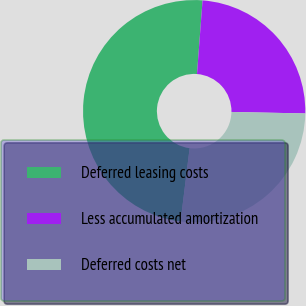Convert chart. <chart><loc_0><loc_0><loc_500><loc_500><pie_chart><fcel>Deferred leasing costs<fcel>Less accumulated amortization<fcel>Deferred costs net<nl><fcel>49.25%<fcel>24.12%<fcel>26.63%<nl></chart> 